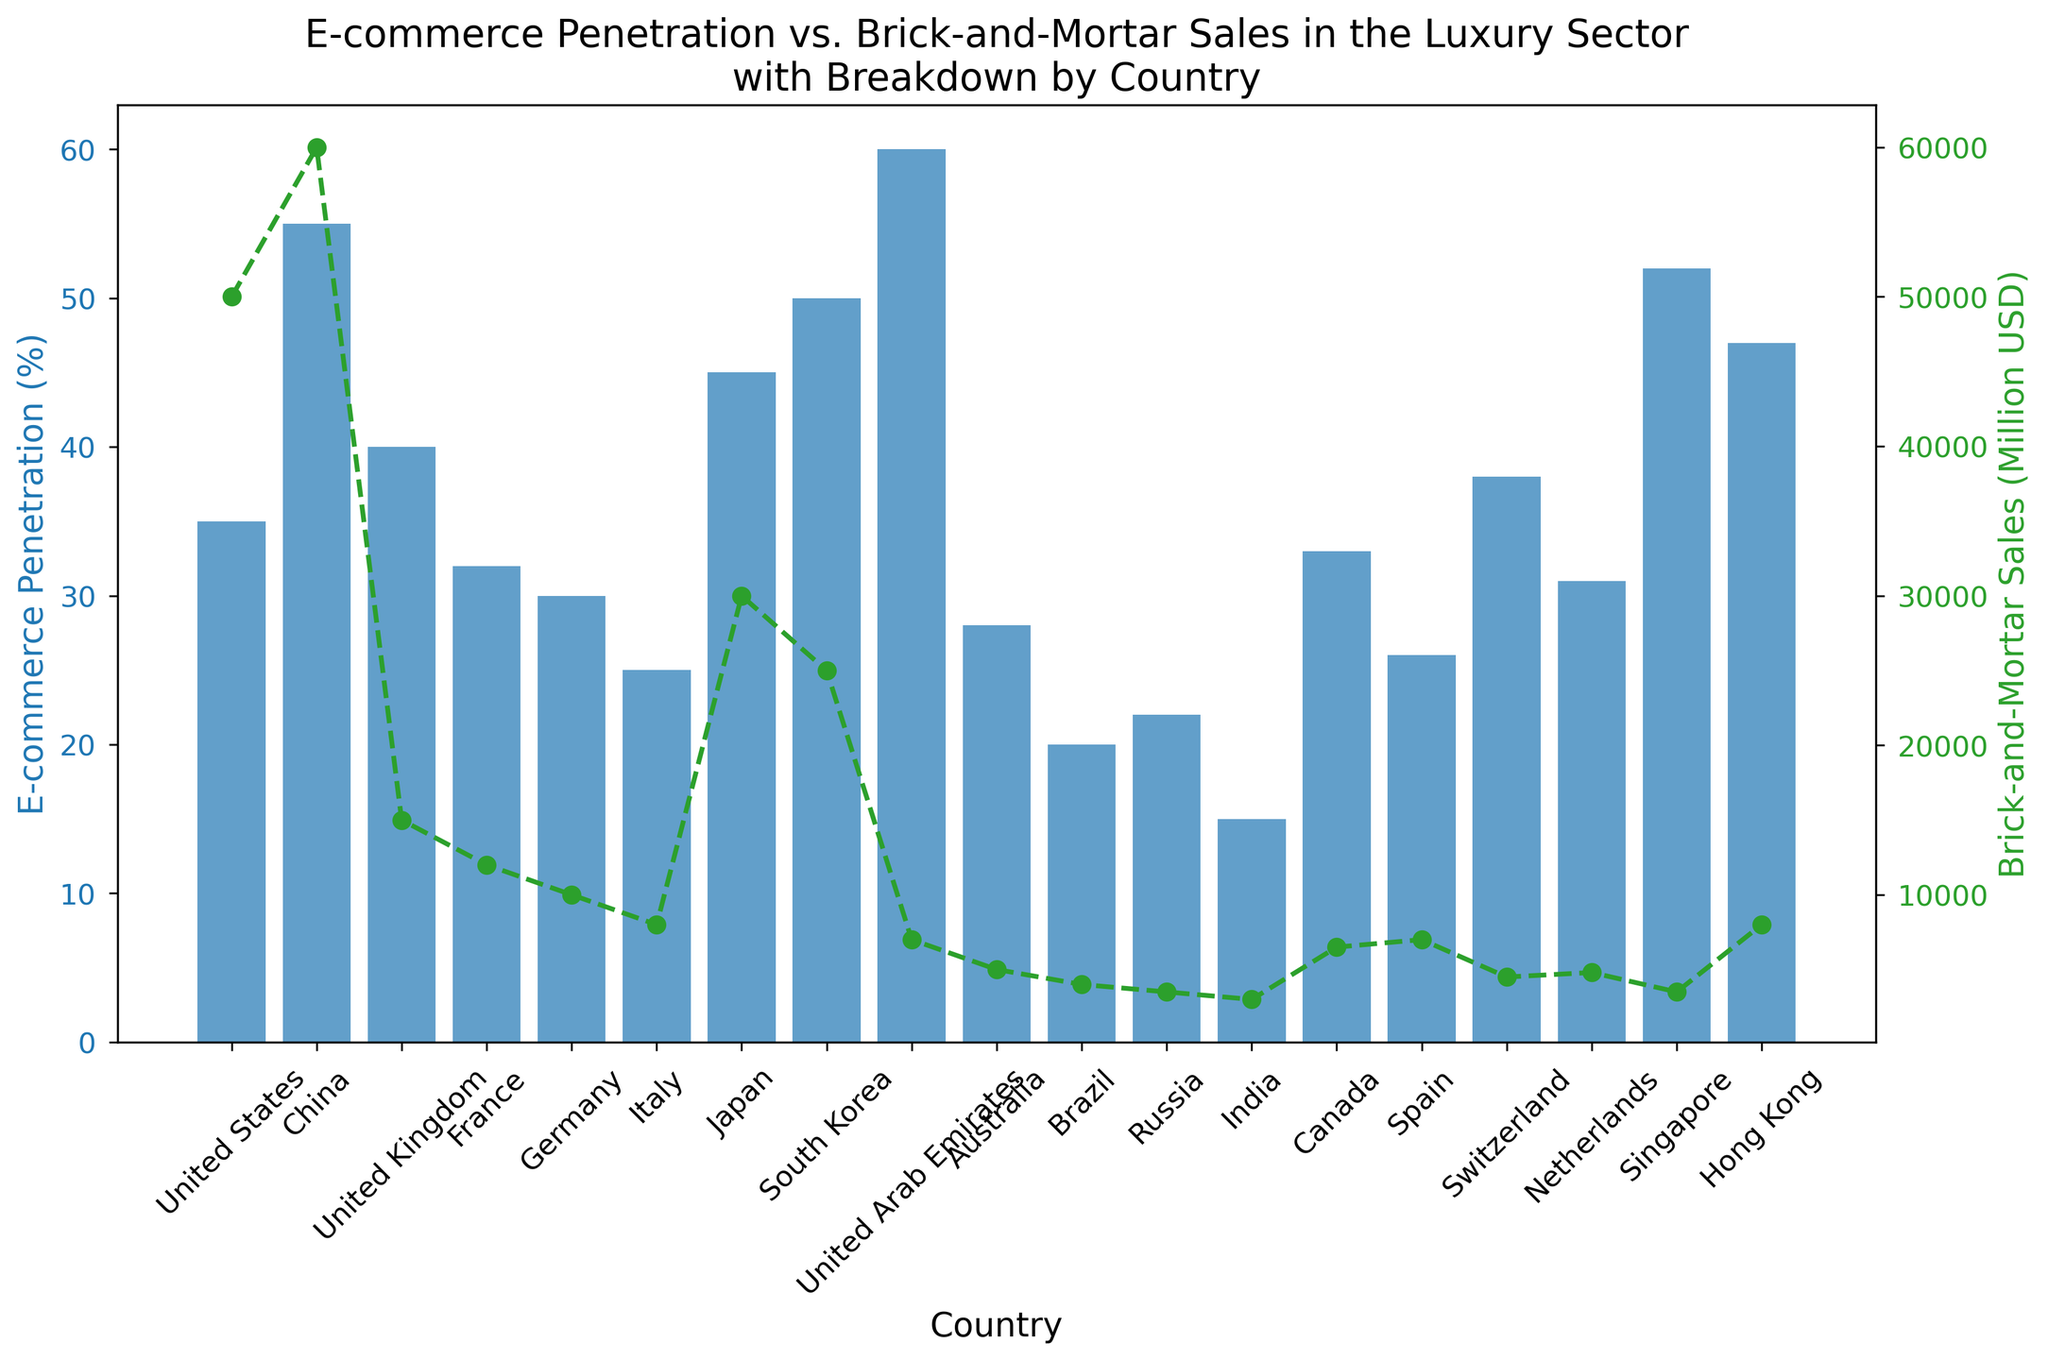What country has the highest e-commerce penetration in the luxury sector? The bar representing the United Arab Emirates is the tallest, indicating the highest e-commerce penetration percentage.
Answer: United Arab Emirates Which country has the lowest brick-and-mortar sales in million USD? The line representing India is the lowest among all the countries on the secondary axis.
Answer: India Compare the e-commerce penetration between Japan and South Korea. Which country has a higher percentage and by how much? Both Japan and South Korea have their respective bars placed near 45% and 50%. South Korea has a higher percentage than Japan by 5%.
Answer: South Korea by 5% Calculate the total brick-and-mortar sales for Italy, France, and Germany combined. The sales for Italy, France, and Germany are 8000, 12000, and 10000 million USD respectively. Summing these gives: 8000 + 12000 + 10000 = 30,000 million USD.
Answer: 30,000 Which country shows a greater balance between e-commerce penetration and brick-and-mortar sales, the United Kingdom or Germany? The UK has a 40% e-commerce penetration and 15,000 million USD in brick-and-mortar sales, while Germany has a 30% penetration and 10,000 million USD in sales. Germany shows a more balanced distribution as the gap between the two metrics is smaller.
Answer: Germany Rank the countries by their e-commerce penetration from highest to lowest. Observing the height of the bars from tallest to shortest, the ranking is: United Arab Emirates, China, Singapore, South Korea, Hong Kong, Japan, United Kingdom, Switzerland, United States, Canada, France, Netherlands, Germany, Spain, Australia, Italy, Russia, Brazil, India.
Answer: United Arab Emirates, China, Singapore, South Korea, Hong Kong, Japan, United Kingdom, Switzerland, United States, Canada, France, Netherlands, Germany, Spain, Australia, Italy, Russia, Brazil, India Calculate the average e-commerce penetration for Italy, Australia, and Canada. The e-commerce penetration percentages for Italy, Australia, and Canada are 25%, 28%, and 33% respectively. The average is: (25 + 28 + 33) / 3 = 28.67%.
Answer: 28.67% Which country has the largest difference between e-commerce penetration and brick-and-mortar sales figures? The United States has the largest difference when you consider its 35% e-commerce penetration and 50,000 million USD in brick-and-mortar sales. The significant gap between the two metrics is visually notable.
Answer: United States Identify the country where the e-commerce penetration closely matches the amount of brick-and-mortar sales. Singapore has both a high e-commerce penetration (52%) and a relatively lower brick-and-mortar sales (3,500 million USD), making the metrics fairly close in terms of relative comparison to other countries.
Answer: Singapore 